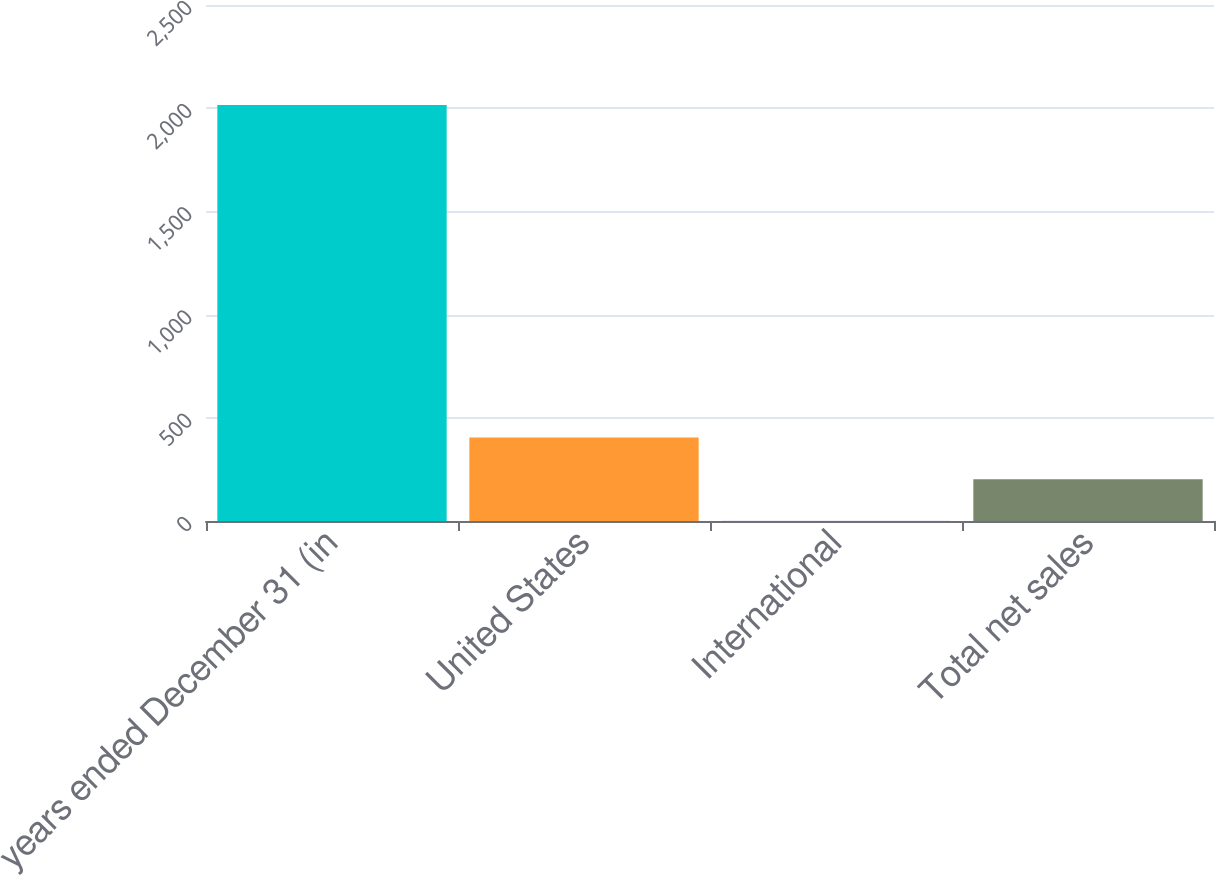Convert chart. <chart><loc_0><loc_0><loc_500><loc_500><bar_chart><fcel>years ended December 31 (in<fcel>United States<fcel>International<fcel>Total net sales<nl><fcel>2016<fcel>404<fcel>1<fcel>202.5<nl></chart> 